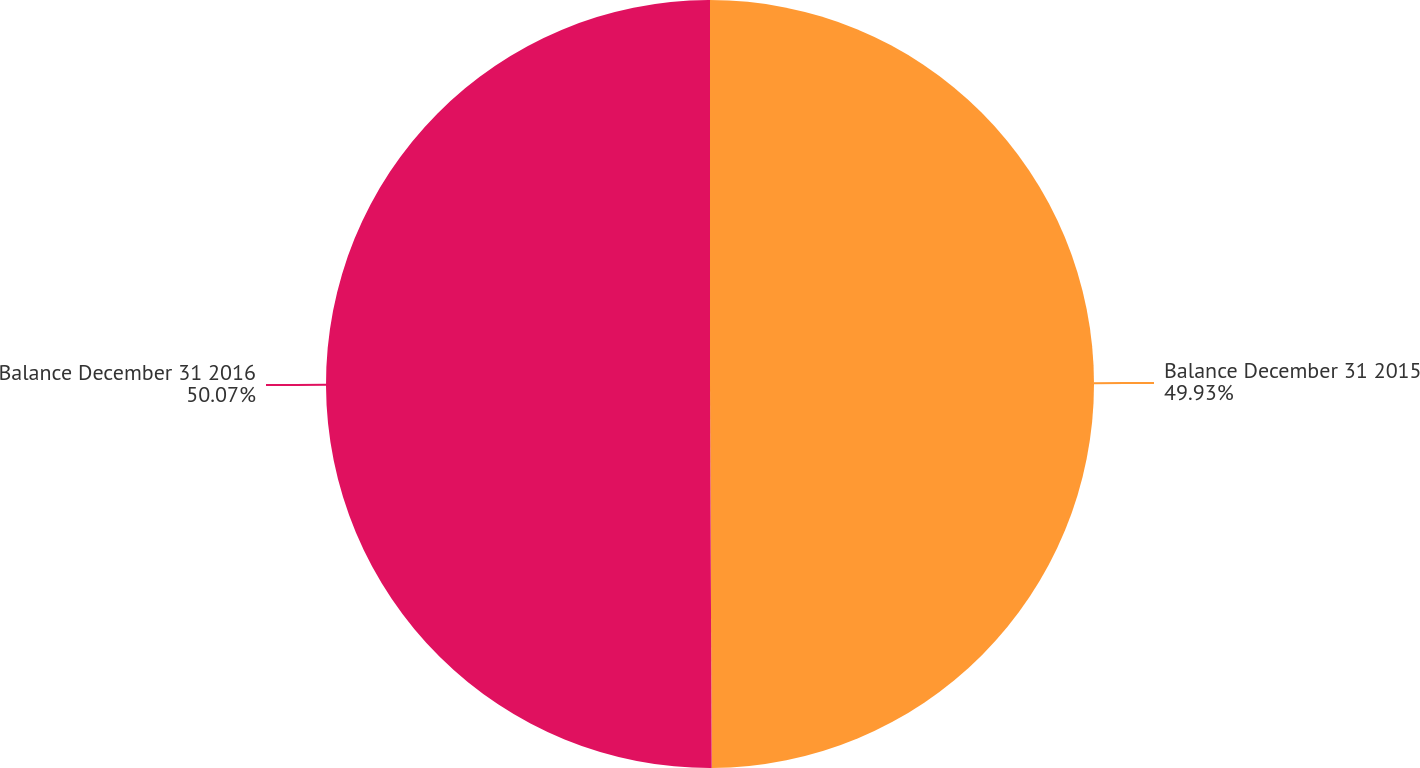Convert chart. <chart><loc_0><loc_0><loc_500><loc_500><pie_chart><fcel>Balance December 31 2015<fcel>Balance December 31 2016<nl><fcel>49.93%<fcel>50.07%<nl></chart> 